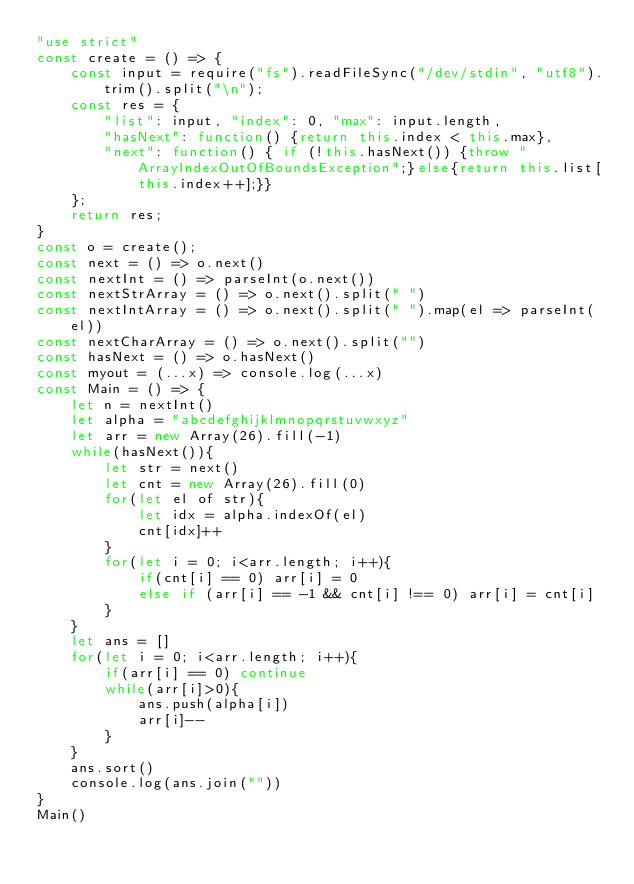Convert code to text. <code><loc_0><loc_0><loc_500><loc_500><_JavaScript_>"use strict"
const create = () => {
    const input = require("fs").readFileSync("/dev/stdin", "utf8").trim().split("\n");
    const res = {
        "list": input, "index": 0, "max": input.length,
        "hasNext": function() {return this.index < this.max},
        "next": function() { if (!this.hasNext()) {throw "ArrayIndexOutOfBoundsException";}else{return this.list[this.index++];}}
    };
    return res;
}
const o = create();
const next = () => o.next()
const nextInt = () => parseInt(o.next())
const nextStrArray = () => o.next().split(" ")
const nextIntArray = () => o.next().split(" ").map(el => parseInt(el))
const nextCharArray = () => o.next().split("")
const hasNext = () => o.hasNext()
const myout = (...x) => console.log(...x)
const Main = () => {
    let n = nextInt()
    let alpha = "abcdefghijklmnopqrstuvwxyz"
    let arr = new Array(26).fill(-1)
    while(hasNext()){
        let str = next()
        let cnt = new Array(26).fill(0)
        for(let el of str){
            let idx = alpha.indexOf(el)
            cnt[idx]++
        }
        for(let i = 0; i<arr.length; i++){
            if(cnt[i] == 0) arr[i] = 0
            else if (arr[i] == -1 && cnt[i] !== 0) arr[i] = cnt[i]
        }
    }
    let ans = []
    for(let i = 0; i<arr.length; i++){
        if(arr[i] == 0) continue
        while(arr[i]>0){
            ans.push(alpha[i])
            arr[i]--
        }
    }
    ans.sort()
    console.log(ans.join(""))
}
Main()

</code> 